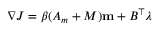<formula> <loc_0><loc_0><loc_500><loc_500>\nabla J = \beta ( A _ { m } + M ) m + B ^ { \top } \lambda</formula> 